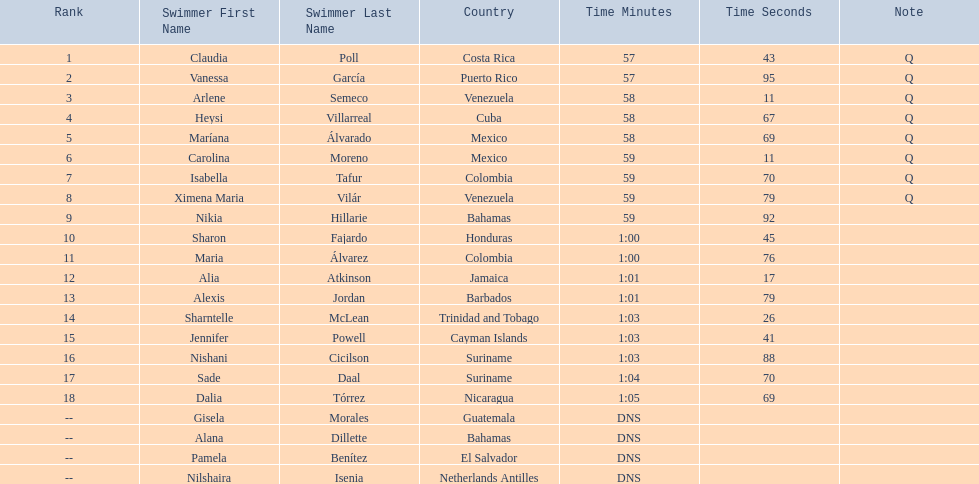Who were all of the swimmers in the women's 100 metre freestyle? Claudia Poll, Vanessa García, Arlene Semeco, Heysi Villarreal, Maríana Álvarado, Carolina Moreno, Isabella Tafur, Ximena Maria Vilár, Nikia Hillarie, Sharon Fajardo, Maria Álvarez, Alia Atkinson, Alexis Jordan, Sharntelle McLean, Jennifer Powell, Nishani Cicilson, Sade Daal, Dalia Tórrez, Gisela Morales, Alana Dillette, Pamela Benítez, Nilshaira Isenia. Where was each swimmer from? Costa Rica, Puerto Rico, Venezuela, Cuba, Mexico, Mexico, Colombia, Venezuela, Bahamas, Honduras, Colombia, Jamaica, Barbados, Trinidad and Tobago, Cayman Islands, Suriname, Suriname, Nicaragua, Guatemala, Bahamas, El Salvador, Netherlands Antilles. What were their ranks? 1, 2, 3, 4, 5, 6, 7, 8, 9, 10, 11, 12, 13, 14, 15, 16, 17, 18, --, --, --, --. Who was in the top eight? Claudia Poll, Vanessa García, Arlene Semeco, Heysi Villarreal, Maríana Álvarado, Carolina Moreno, Isabella Tafur, Ximena Maria Vilár. Of those swimmers, which one was from cuba? Heysi Villarreal. 